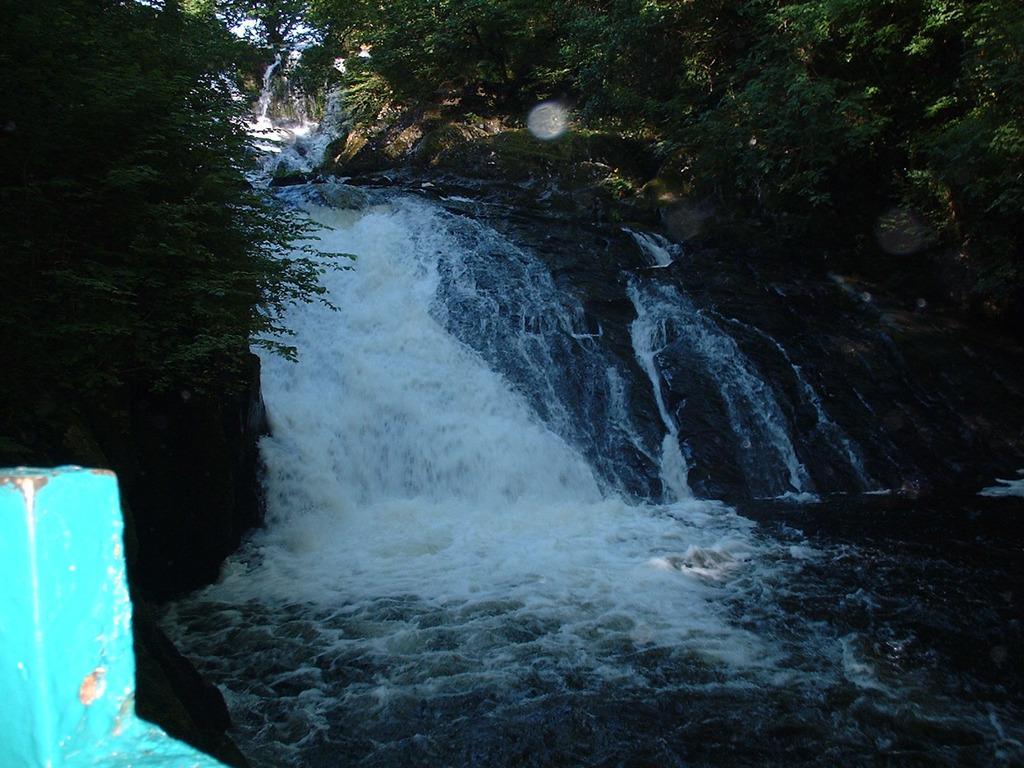What is one of the natural elements visible in the image? There is water visible in the image. What type of vegetation can be seen in the image? There are trees in the image. Can you describe the metal object in the image? There is a blue metal object in the image. Where is the lamp located in the image? There is no lamp present in the image. How many steps can be seen leading up to the market in the image? There is no market or steps present in the image. 